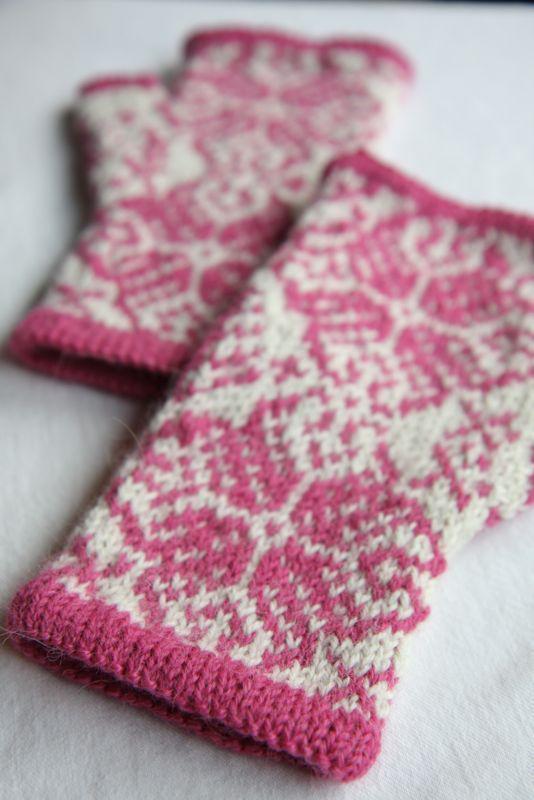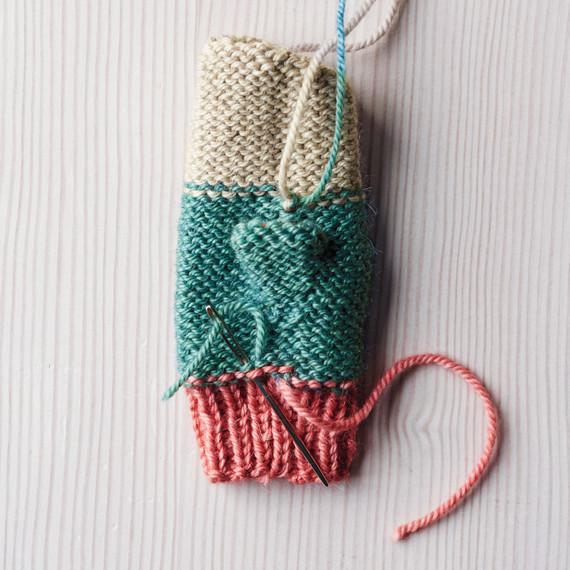The first image is the image on the left, the second image is the image on the right. Assess this claim about the two images: "There is a pair of mittens and one is in the process of being knitted.". Correct or not? Answer yes or no. Yes. The first image is the image on the left, the second image is the image on the right. Given the left and right images, does the statement "An image shows some type of needle inserted into the yarn of a mitten." hold true? Answer yes or no. Yes. 